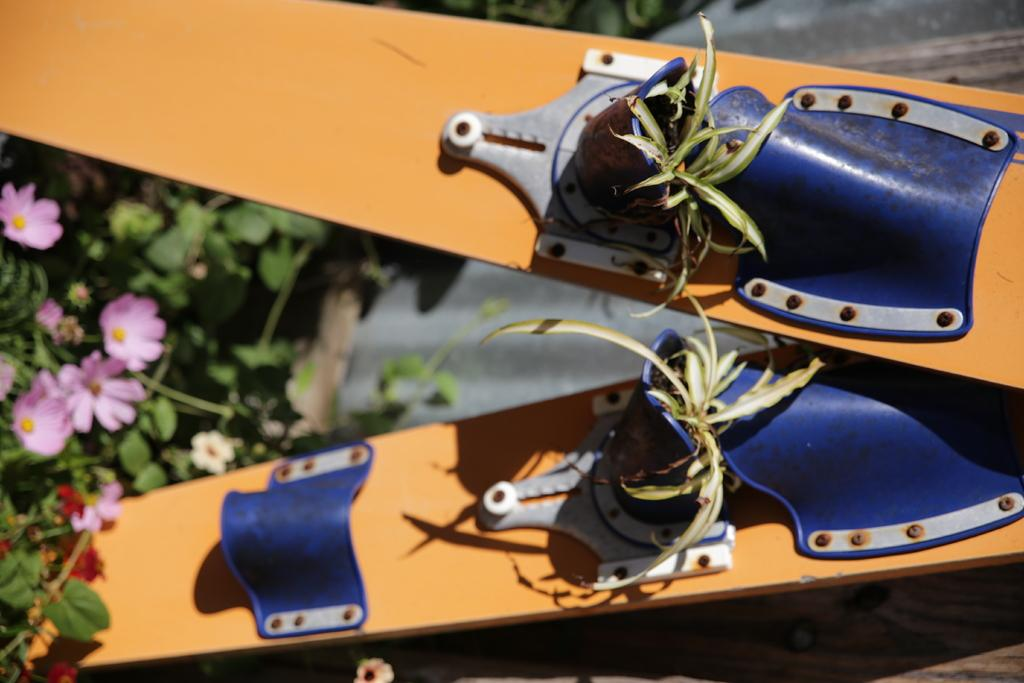What types of living organisms can be seen in the image? Plants and flowers are visible in the image. What else can be seen in the image besides living organisms? There are objects in the image. What substance is being used to start the engine in the image? There is no engine or substance present in the image; it features plants, flowers, and objects. 